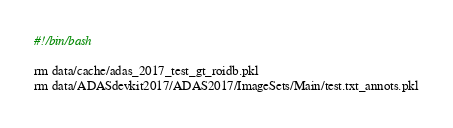Convert code to text. <code><loc_0><loc_0><loc_500><loc_500><_Bash_>#!/bin/bash

rm data/cache/adas_2017_test_gt_roidb.pkl
rm data/ADASdevkit2017/ADAS2017/ImageSets/Main/test.txt_annots.pkl
</code> 